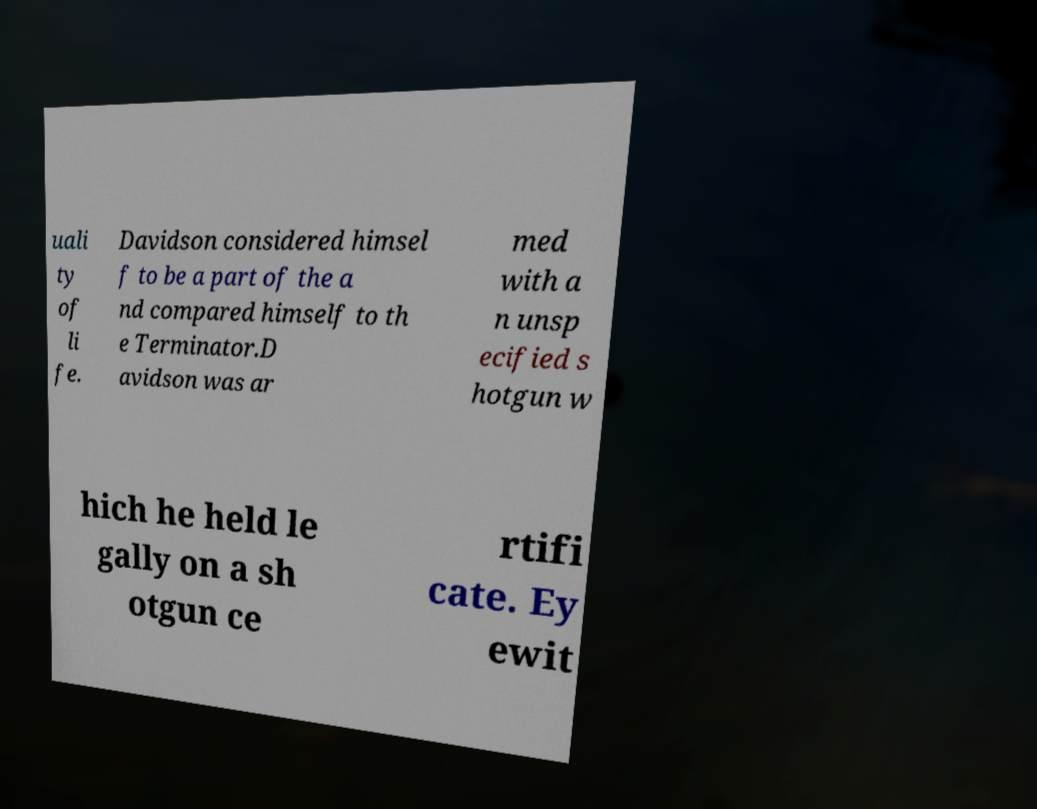Could you assist in decoding the text presented in this image and type it out clearly? uali ty of li fe. Davidson considered himsel f to be a part of the a nd compared himself to th e Terminator.D avidson was ar med with a n unsp ecified s hotgun w hich he held le gally on a sh otgun ce rtifi cate. Ey ewit 